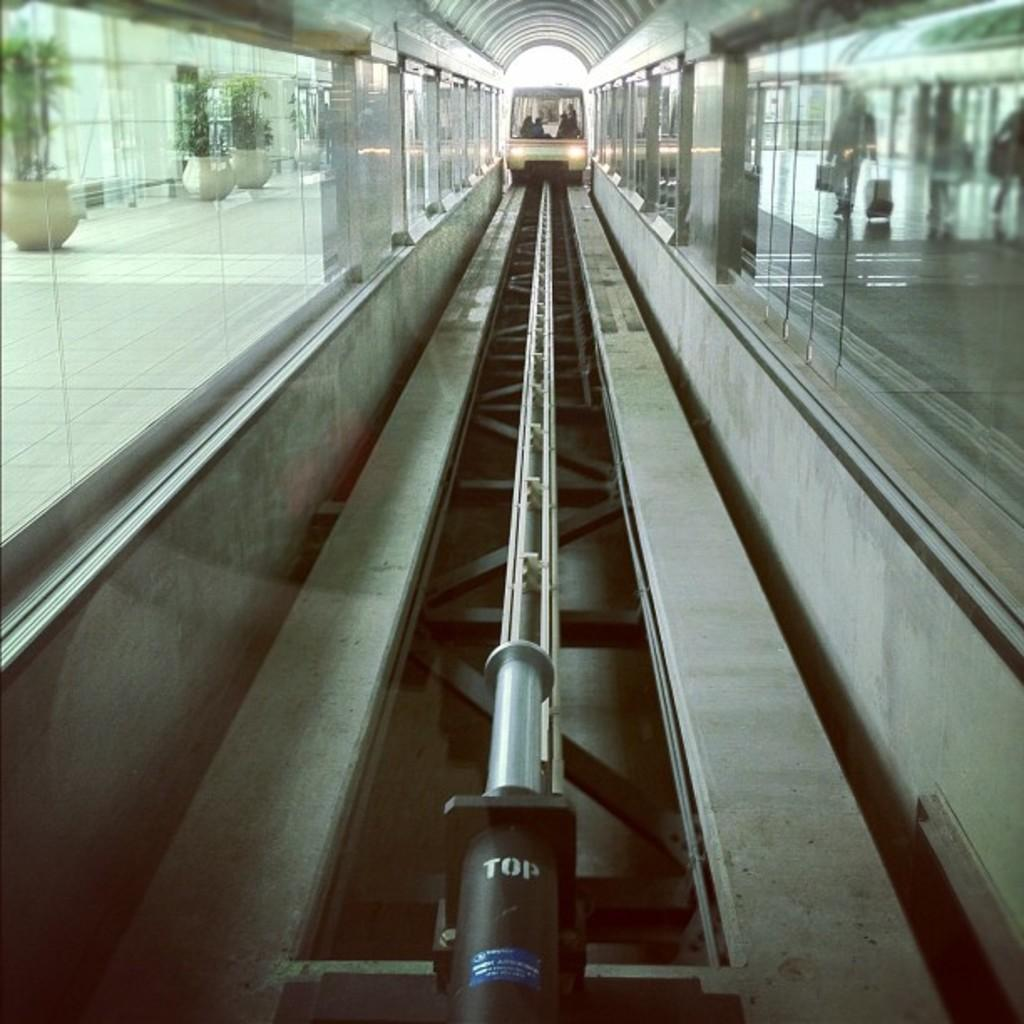What is the main subject of the image? The main subject of the image is a train. What is the train's position in the image? The train is on a track. What feature can be seen on the train in the image? There are glass walls visible in the image. What can be seen in the background of the image? There are plants in the background of the image. What is the color of the plants in the image? The plants are green in color. What type of curtain can be seen hanging from the train's windows in the image? There are no curtains visible in the image; the train has glass walls instead. What type of skin condition is visible on the plants in the image? There are no skin conditions present in the image, as the plants are not living organisms with skin. 